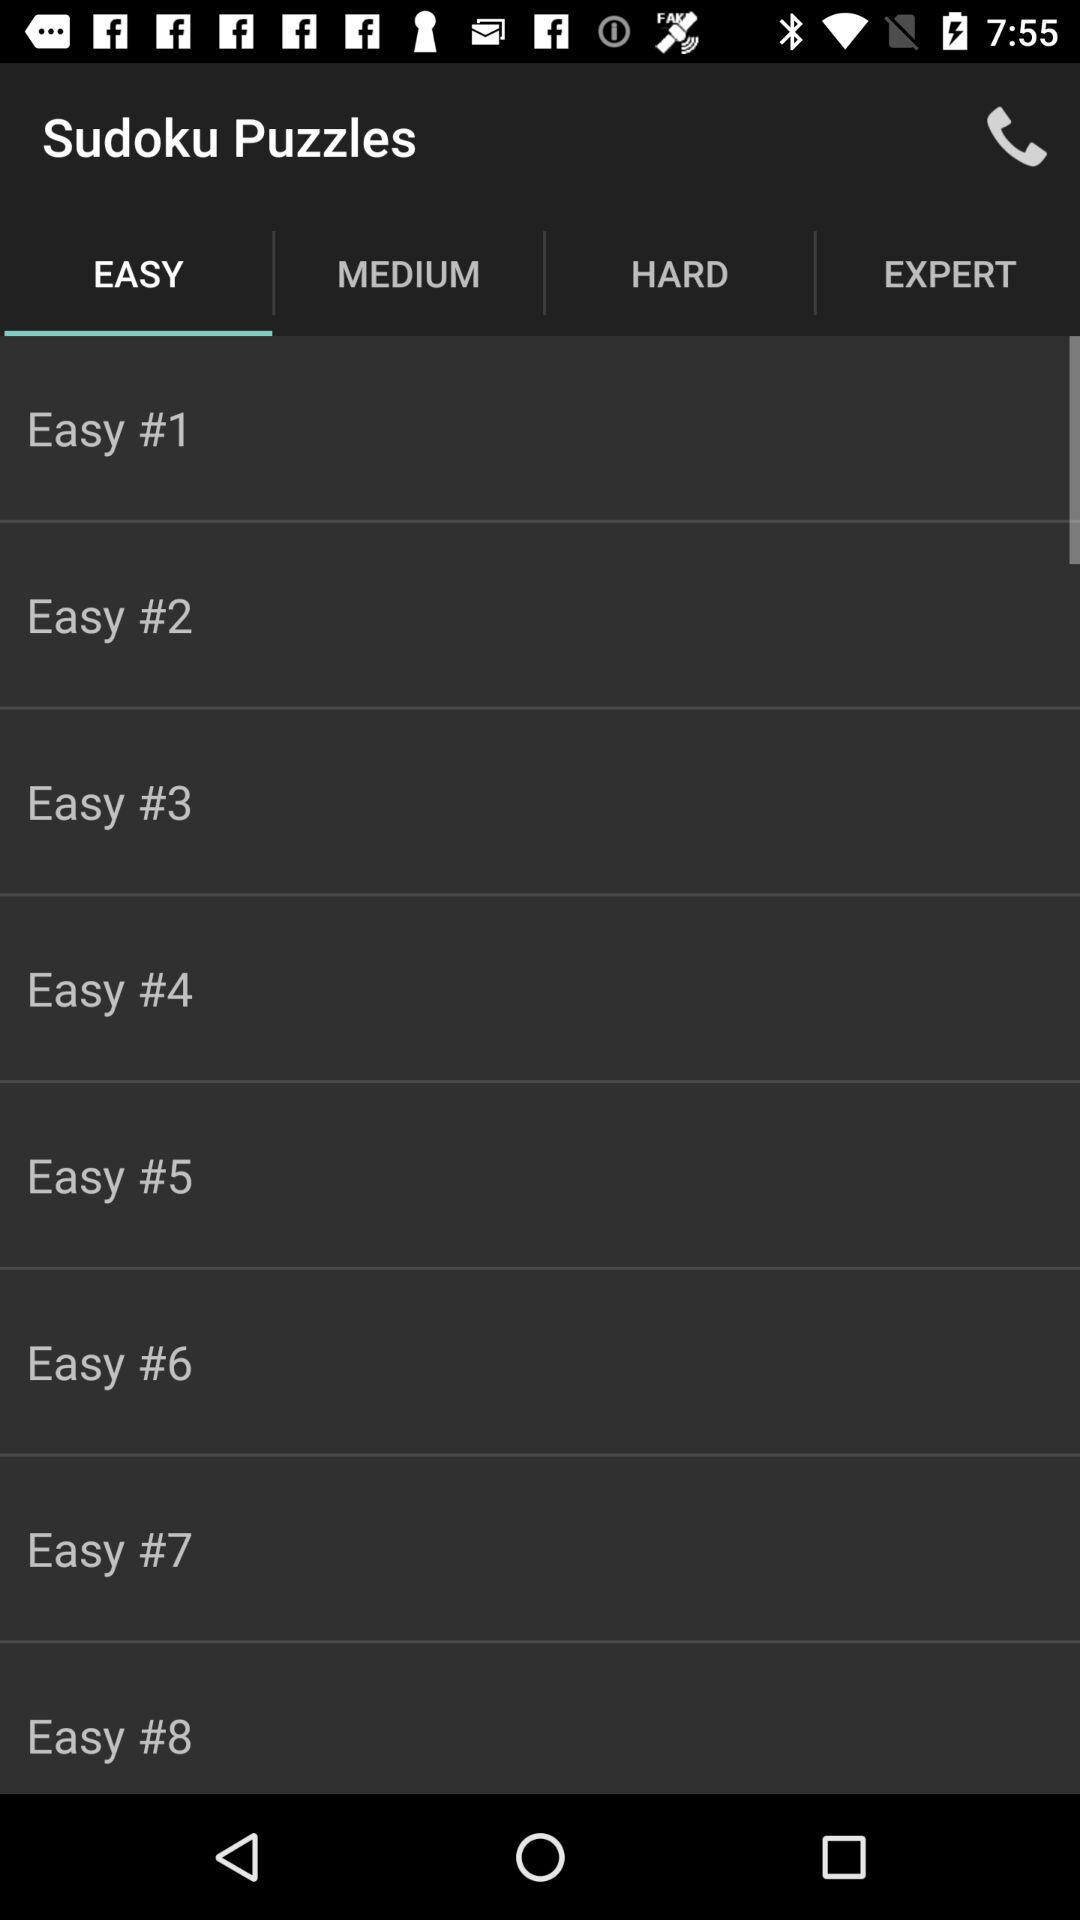Which option is selected? The selected option is "EASY". 